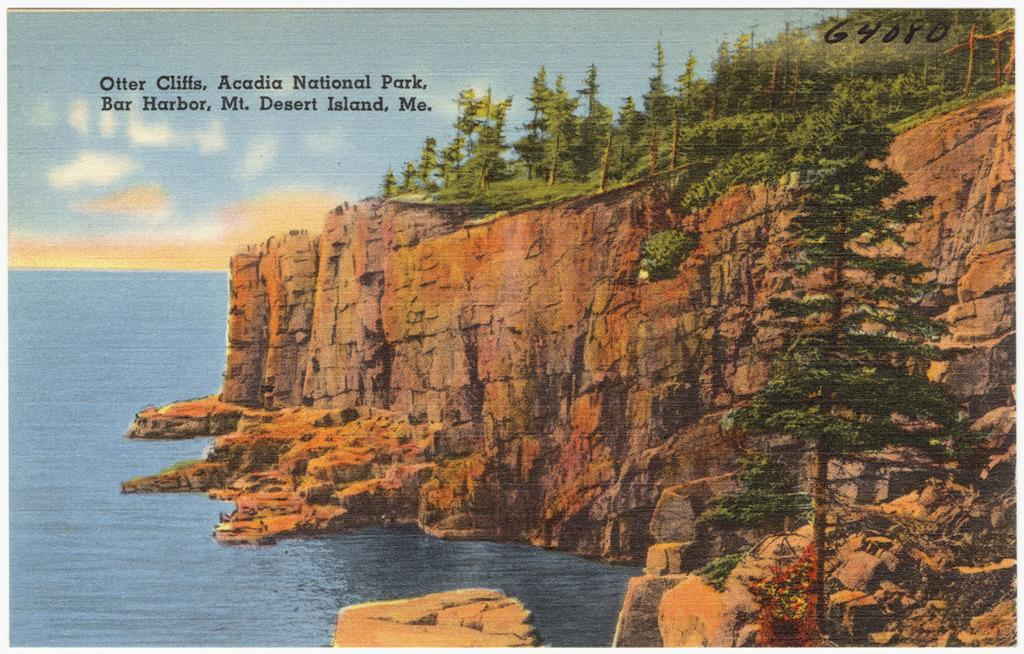What type of visual is the image? The image is a poster. What landscape feature can be seen in the poster? There is a hill in the poster. What type of vegetation is present in the poster? There are trees in the poster. What natural element is depicted in the poster? There is water in the poster. What part of the sky is visible in the poster? There is sky in the poster. Are there any words on the poster? Yes, there are words on the poster. What type of gun is being used to shoot the pot in the poster? There is no gun or pot present in the poster; it features a hill, trees, water, sky, and words. Can you see a twig being used as a tool by the creature in the poster? There is no creature or twig present in the poster. 